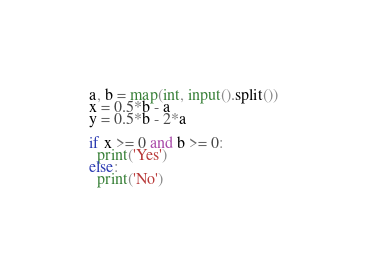<code> <loc_0><loc_0><loc_500><loc_500><_Python_>a, b = map(int, input().split())
x = 0.5*b - a
y = 0.5*b - 2*a
 
if x >= 0 and b >= 0:
  print('Yes')
else:
  print('No')</code> 